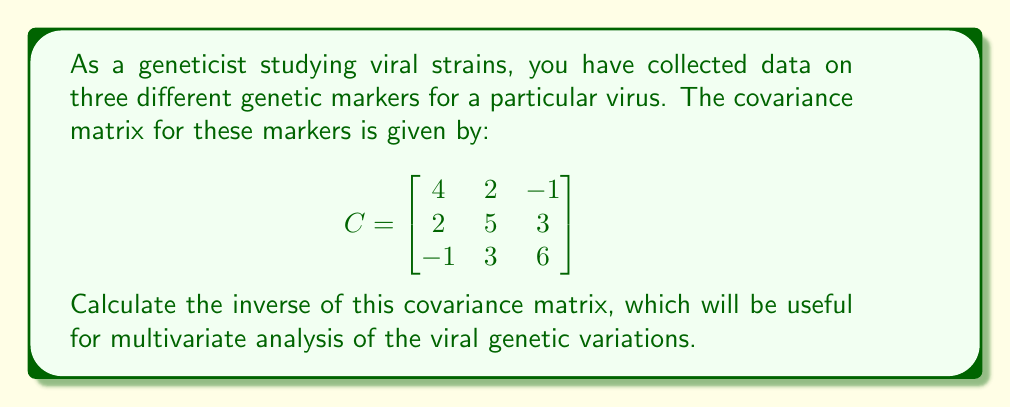Solve this math problem. To find the inverse of the 3x3 covariance matrix, we'll use the following steps:

1. Calculate the determinant of the matrix.
2. Find the adjugate matrix.
3. Divide the adjugate matrix by the determinant.

Step 1: Calculate the determinant
$$
\begin{align}
det(C) &= 4(5(6) - 3(3)) - 2(2(6) - (-1)(3)) + (-1)(2(3) - (-1)(5)) \\
&= 4(30 - 9) - 2(12 + 3) + (-1)(6 + 5) \\
&= 4(21) - 2(15) - 11 \\
&= 84 - 30 - 11 \\
&= 43
\end{align}
$$

Step 2: Find the adjugate matrix
First, we need to calculate the cofactor matrix:

$$
\begin{align}
C_{11} &= +(5(6) - 3(3)) = +21 \\
C_{12} &= -(2(6) - (-1)(3)) = -15 \\
C_{13} &= +(2(3) - 5(-1)) = +11 \\
C_{21} &= -(2(6) - (-1)(3)) = -15 \\
C_{22} &= +(4(6) - (-1)(-1)) = +23 \\
C_{23} &= -(4(3) - 2(-1)) = -14 \\
C_{31} &= +(2(3) - 5(2)) = -4 \\
C_{32} &= -(4(3) - (-1)(2)) = -14 \\
C_{33} &= +(4(5) - 2(2)) = +16
\end{align}
$$

The adjugate matrix is the transpose of the cofactor matrix:

$$
adj(C) = \begin{bmatrix}
21 & -15 & -4 \\
-15 & 23 & -14 \\
11 & -14 & 16
\end{bmatrix}
$$

Step 3: Divide the adjugate matrix by the determinant
The inverse of the covariance matrix is:

$$
C^{-1} = \frac{1}{det(C)} \cdot adj(C) = \frac{1}{43} \begin{bmatrix}
21 & -15 & -4 \\
-15 & 23 & -14 \\
11 & -14 & 16
\end{bmatrix}
$$
Answer: The inverse of the covariance matrix is:

$$
C^{-1} = \frac{1}{43} \begin{bmatrix}
21 & -15 & -4 \\
-15 & 23 & -14 \\
11 & -14 & 16
\end{bmatrix}
$$ 